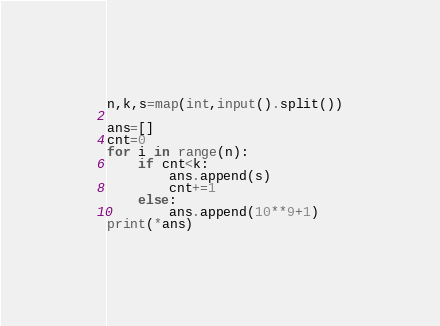<code> <loc_0><loc_0><loc_500><loc_500><_Python_>n,k,s=map(int,input().split())

ans=[]
cnt=0
for i in range(n):
    if cnt<k:
        ans.append(s)
        cnt+=1
    else:
        ans.append(10**9+1)
print(*ans)
</code> 